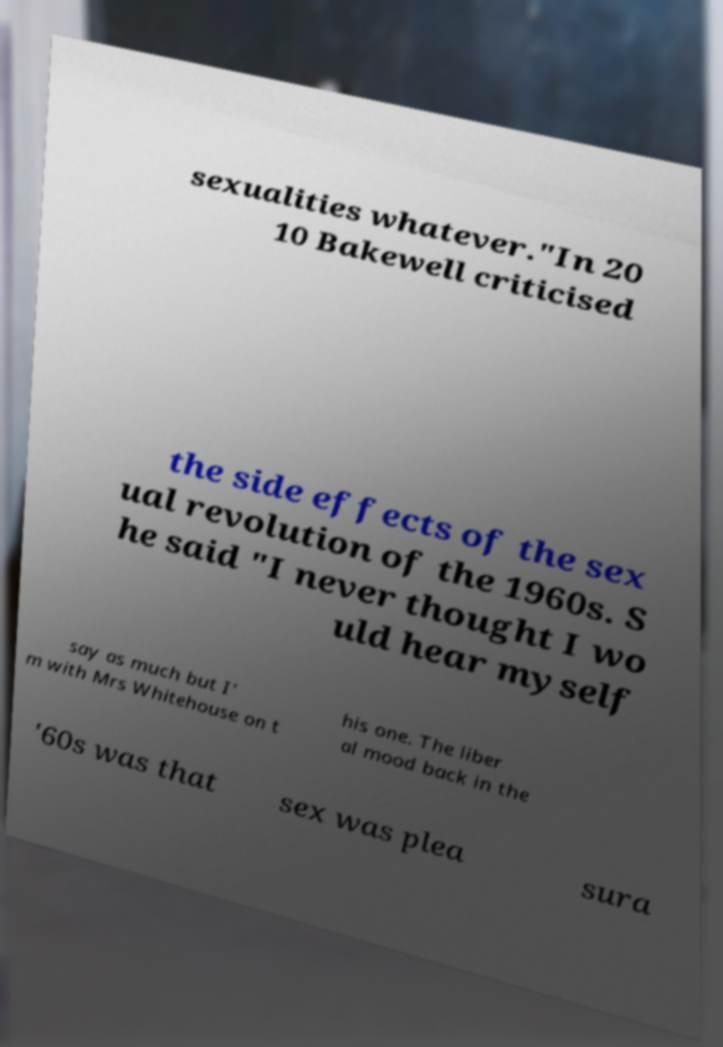Can you accurately transcribe the text from the provided image for me? sexualities whatever."In 20 10 Bakewell criticised the side effects of the sex ual revolution of the 1960s. S he said "I never thought I wo uld hear myself say as much but I' m with Mrs Whitehouse on t his one. The liber al mood back in the '60s was that sex was plea sura 